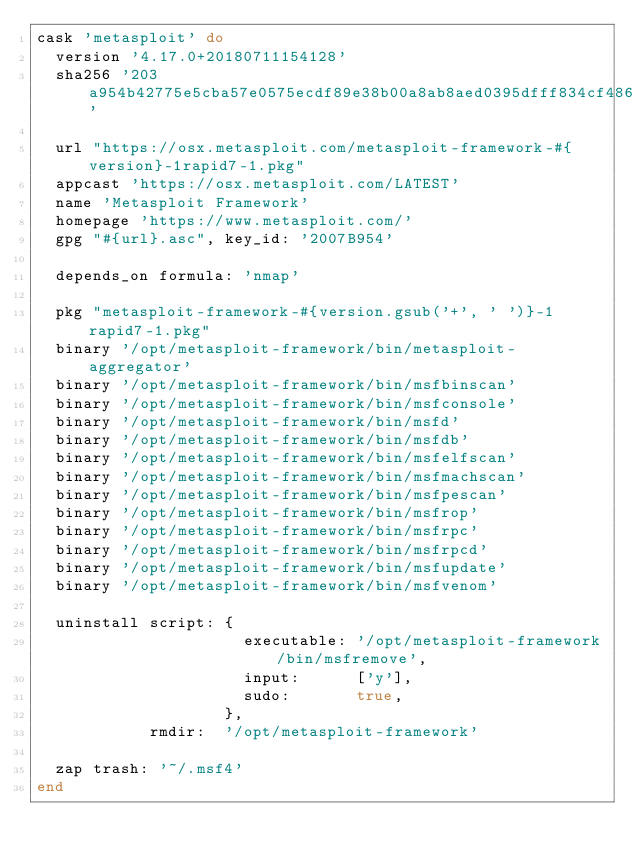Convert code to text. <code><loc_0><loc_0><loc_500><loc_500><_Ruby_>cask 'metasploit' do
  version '4.17.0+20180711154128'
  sha256 '203a954b42775e5cba57e0575ecdf89e38b00a8ab8aed0395dfff834cf48695a'

  url "https://osx.metasploit.com/metasploit-framework-#{version}-1rapid7-1.pkg"
  appcast 'https://osx.metasploit.com/LATEST'
  name 'Metasploit Framework'
  homepage 'https://www.metasploit.com/'
  gpg "#{url}.asc", key_id: '2007B954'

  depends_on formula: 'nmap'

  pkg "metasploit-framework-#{version.gsub('+', ' ')}-1rapid7-1.pkg"
  binary '/opt/metasploit-framework/bin/metasploit-aggregator'
  binary '/opt/metasploit-framework/bin/msfbinscan'
  binary '/opt/metasploit-framework/bin/msfconsole'
  binary '/opt/metasploit-framework/bin/msfd'
  binary '/opt/metasploit-framework/bin/msfdb'
  binary '/opt/metasploit-framework/bin/msfelfscan'
  binary '/opt/metasploit-framework/bin/msfmachscan'
  binary '/opt/metasploit-framework/bin/msfpescan'
  binary '/opt/metasploit-framework/bin/msfrop'
  binary '/opt/metasploit-framework/bin/msfrpc'
  binary '/opt/metasploit-framework/bin/msfrpcd'
  binary '/opt/metasploit-framework/bin/msfupdate'
  binary '/opt/metasploit-framework/bin/msfvenom'

  uninstall script: {
                      executable: '/opt/metasploit-framework/bin/msfremove',
                      input:      ['y'],
                      sudo:       true,
                    },
            rmdir:  '/opt/metasploit-framework'

  zap trash: '~/.msf4'
end
</code> 